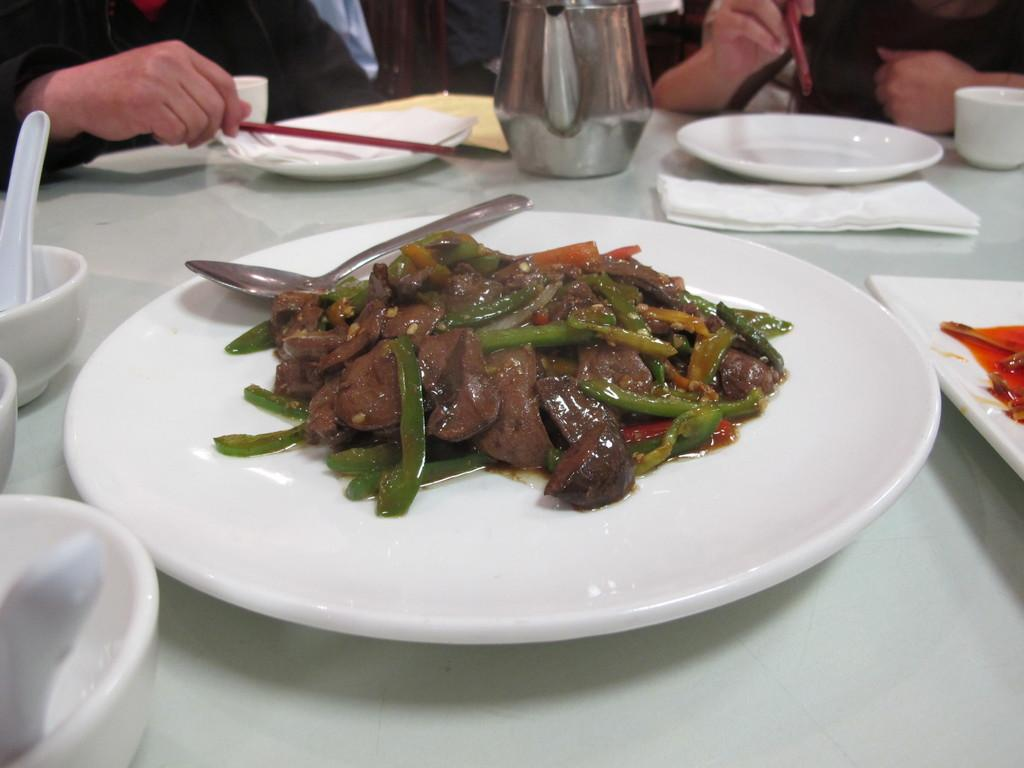Who or what can be seen in the image? There are people in the image. What is the color of the table in the image? The table in the image is white. What type of items are present on the table? Food items, spoons, white color plates, bowls, and tissue papers are on the table. Are there any other objects on the table besides the ones mentioned? Yes, there are other objects on the table. What color are the sticks used for stirring in the image? There are no sticks used for stirring present in the image. 